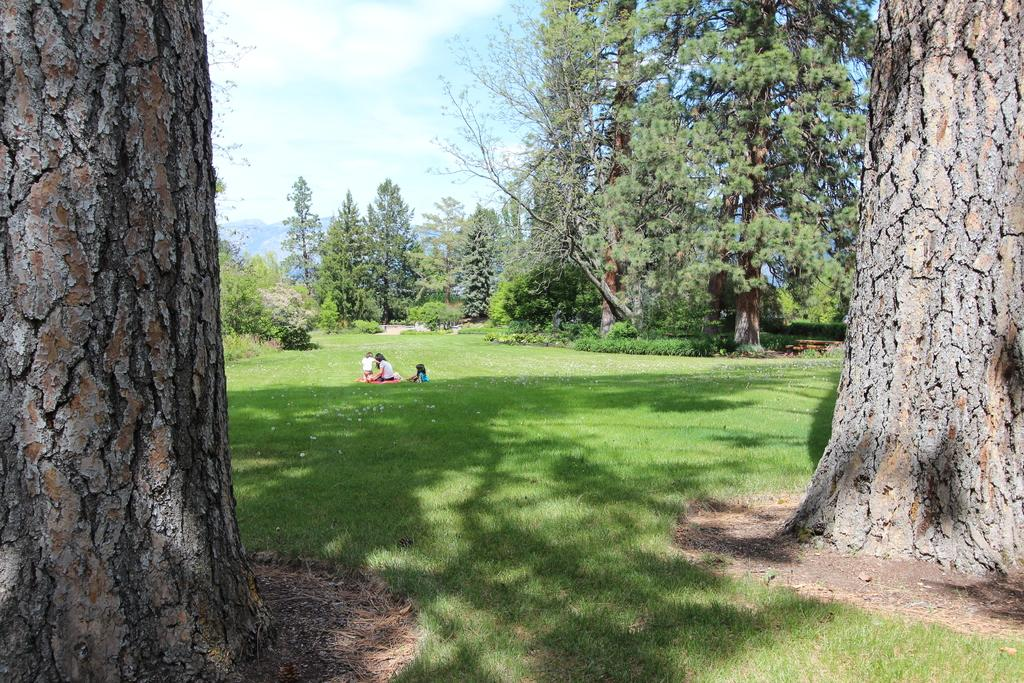What type of natural elements can be seen in the image? There are trees in the image. What are the people in the image doing? The people are sitting on the ground in the image. What colors can be seen in the sky in the image? The sky is blue and white in color. Where is the gold spot on the tree in the image? There is no gold spot on any tree in the image, as the trees are not described as having any gold features. 